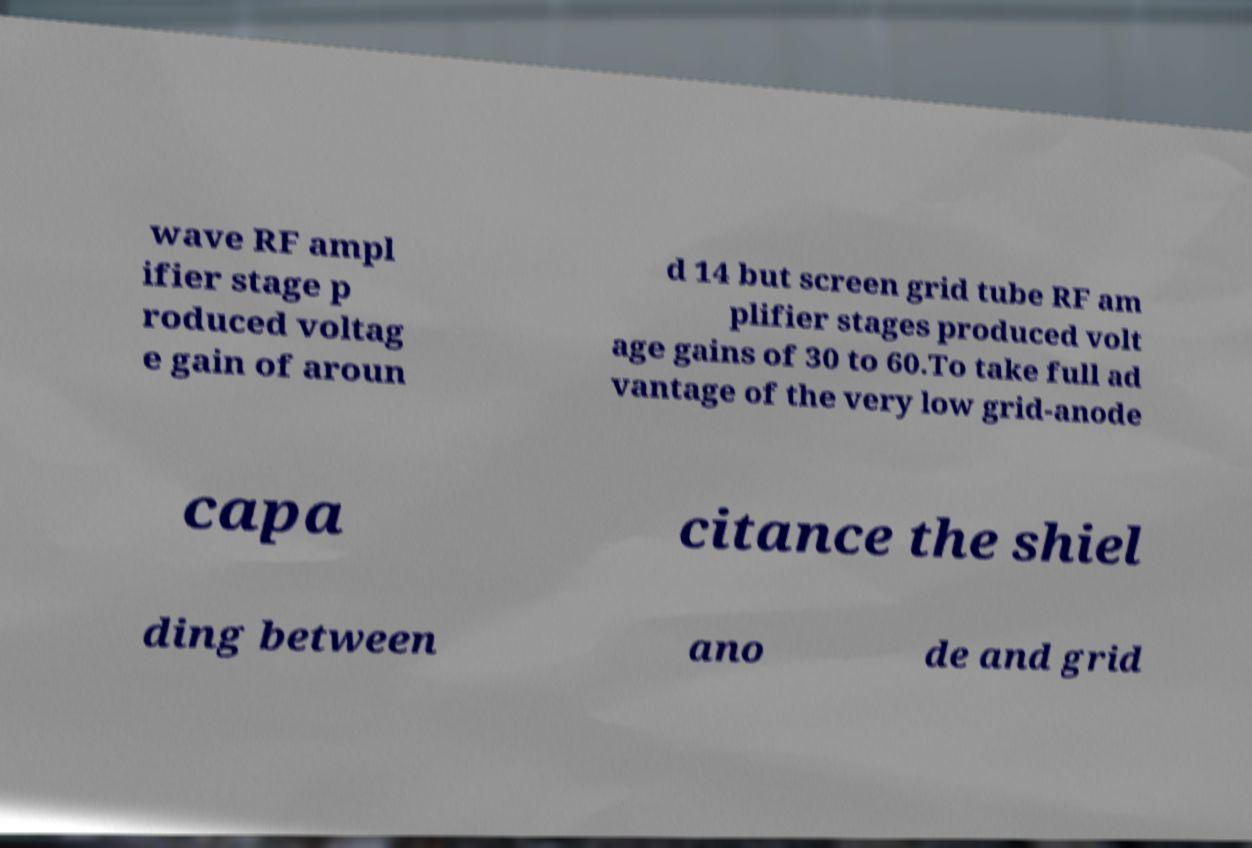What messages or text are displayed in this image? I need them in a readable, typed format. wave RF ampl ifier stage p roduced voltag e gain of aroun d 14 but screen grid tube RF am plifier stages produced volt age gains of 30 to 60.To take full ad vantage of the very low grid-anode capa citance the shiel ding between ano de and grid 